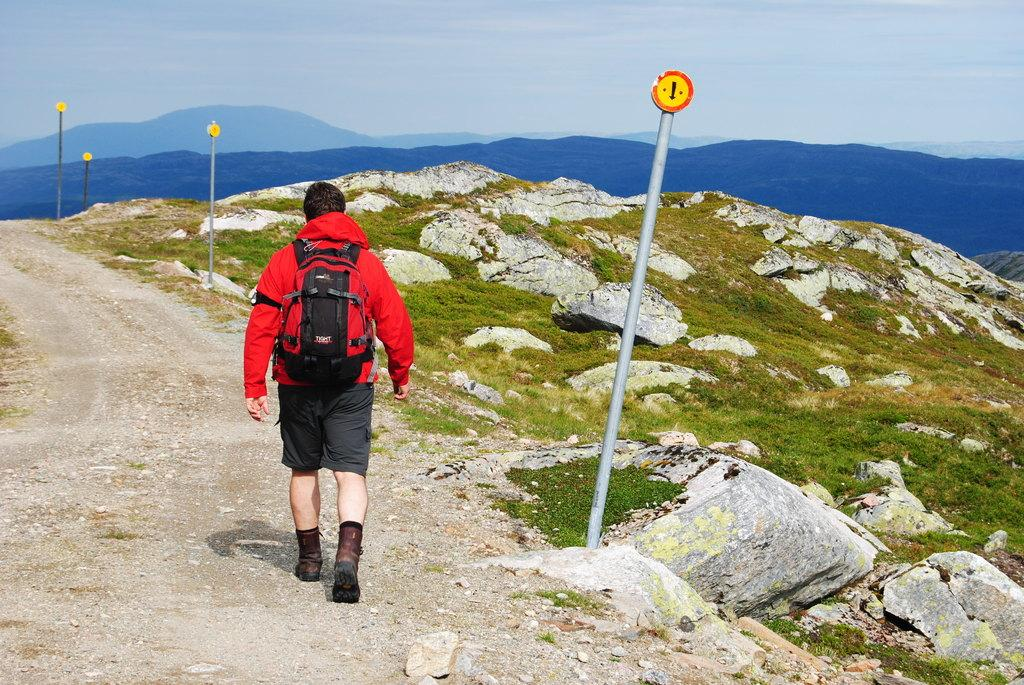What is the main subject of the image? There is a person walking on the road. What can be seen in the background of the image? There is a mountain, a pole, water, and the sky visible in the background. Can you describe the landscape in the image? The image features a road with a person walking, and there is a mountain, a pole, water, and the sky visible in the background. What is the rate of the airplane flying in the image? There is no airplane present in the image, so it is not possible to determine the rate at which it might be flying. 